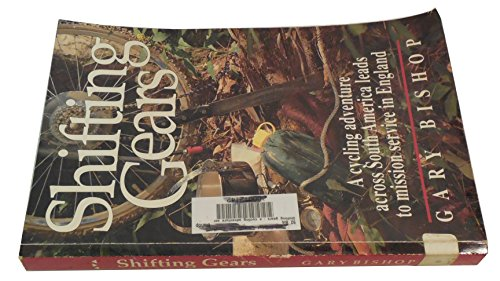Is this book related to Business & Money? No, this book isn't related to Business & Money. Instead, it revolves around adventurous travel and personal growth through unique experiences. 